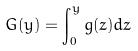Convert formula to latex. <formula><loc_0><loc_0><loc_500><loc_500>G ( y ) = \int _ { 0 } ^ { y } g ( z ) d z</formula> 